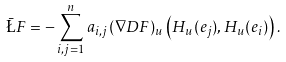Convert formula to latex. <formula><loc_0><loc_0><loc_500><loc_500>\bar { \L } F = - \sum _ { i , j = 1 } ^ { n } a _ { i , j } ( \nabla D F ) _ { u } \left ( H _ { u } ( e _ { j } ) , H _ { u } ( e _ { i } ) \right ) .</formula> 